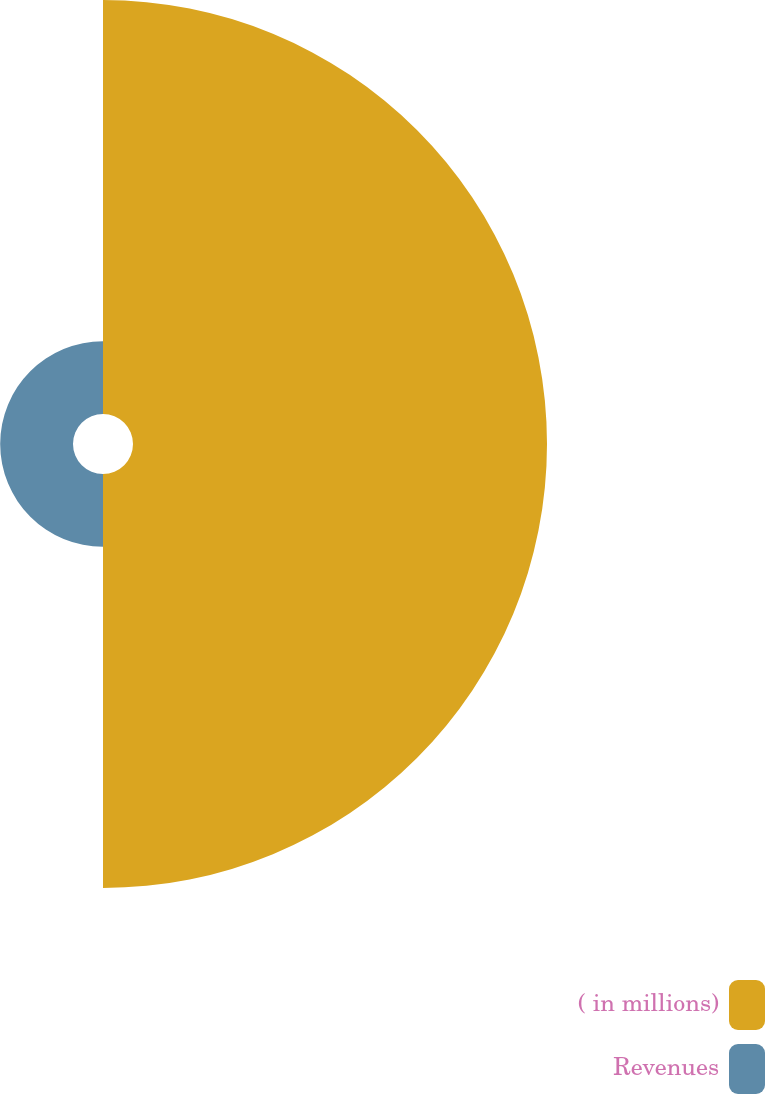<chart> <loc_0><loc_0><loc_500><loc_500><pie_chart><fcel>( in millions)<fcel>Revenues<nl><fcel>85.04%<fcel>14.96%<nl></chart> 